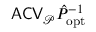<formula> <loc_0><loc_0><loc_500><loc_500>A C V _ { \mathcal { P } } \hat { P } _ { o p t } ^ { - 1 }</formula> 